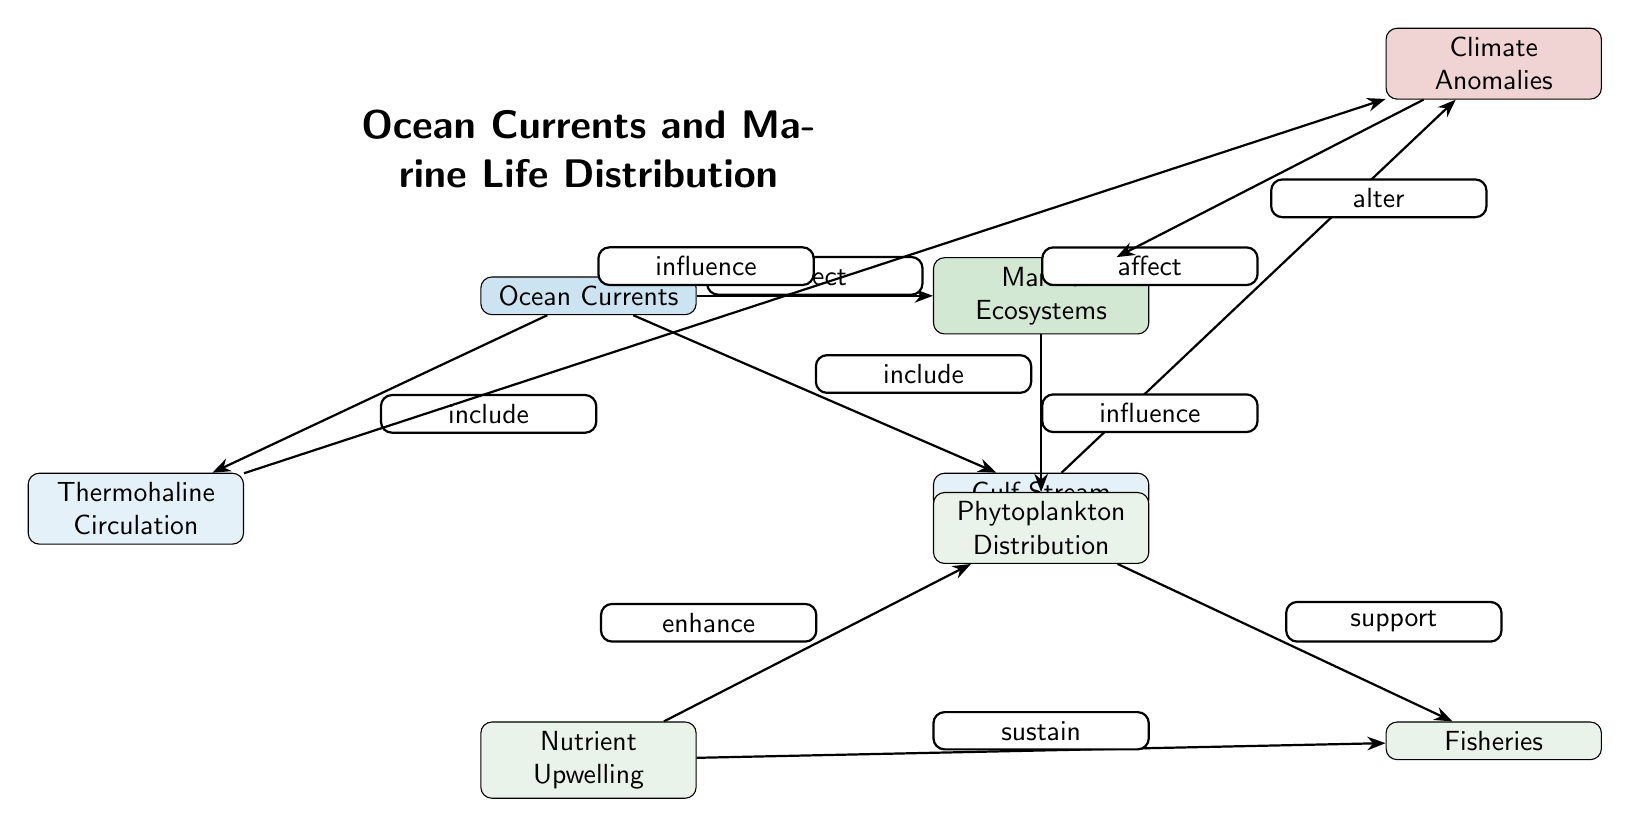What are the two main types of ocean currents shown in the diagram? The diagram clearly identifies "Thermohaline Circulation" and "Gulf Stream" as the two main types of ocean currents. They are positioned as nodes branching from the central node "Ocean Currents."
Answer: Thermohaline Circulation, Gulf Stream How many nodes are there that represent ecological aspects? The ecological aspects are represented by the nodes "Marine Ecosystems," "Phytoplankton Distribution," "Nutrient Upwelling," and "Fisheries." Counting these nodes gives a total of four.
Answer: Four Which node influences the "Marine Ecosystems"? The "Ocean Currents" node is directly connected to "Marine Ecosystems" with the relationship "affect," indicating that ocean currents exert influence over marine ecosystems.
Answer: Ocean Currents Identify the relationship between "Thermohaline Circulation" and "Climate Anomalies". The relationship between "Thermohaline Circulation" and "Climate Anomalies" is defined by the edge labeled "influence." This indicates that changes or characteristics in thermohaline circulation can influence climate anomalies.
Answer: Influence How does "Nutrient Upwelling" affect "Phytoplankton Distribution"? The "Nutrient Upwelling" node has a direct edge to "Phytoplankton Distribution" labeled "enhance." This means that nutrient upwelling contributes positively to the distribution of phytoplankton in marine ecosystems.
Answer: Enhance What role does "Climate Anomalies" play in relation to "Marine Ecosystems"? The "Climate Anomalies" node alters "Marine Ecosystems," according to the relationship specified by the edge labeled "alter." Changes in climate anomalies therefore have a direct impact on marine ecosystems.
Answer: Alter Which aspect of marine life distribution is supported by phytoplankton? The "Fisheries" node connects to "Phytoplankton Distribution" with the edge labeled "support," indicating that the presence and distribution of phytoplankton directly influences fisheries.
Answer: Fisheries How do ocean currents relate to the distribution of marine life in general? The node "Marine Ecosystems" is affected by ocean currents, as illustrated by the edge labeled "affect." This suggests that ocean currents play a crucial role in determining where marine life is located.
Answer: Affect Explain how "Nutrient Upwelling" sustains fisheries. "Nutrient Upwelling" is linked to "Fisheries" with the edge labeled "sustain." This indicates that nutrient upwelling provides essential resources that are necessary for the survival and growth of fish populations, thereby sustaining fisheries.
Answer: Sustain 